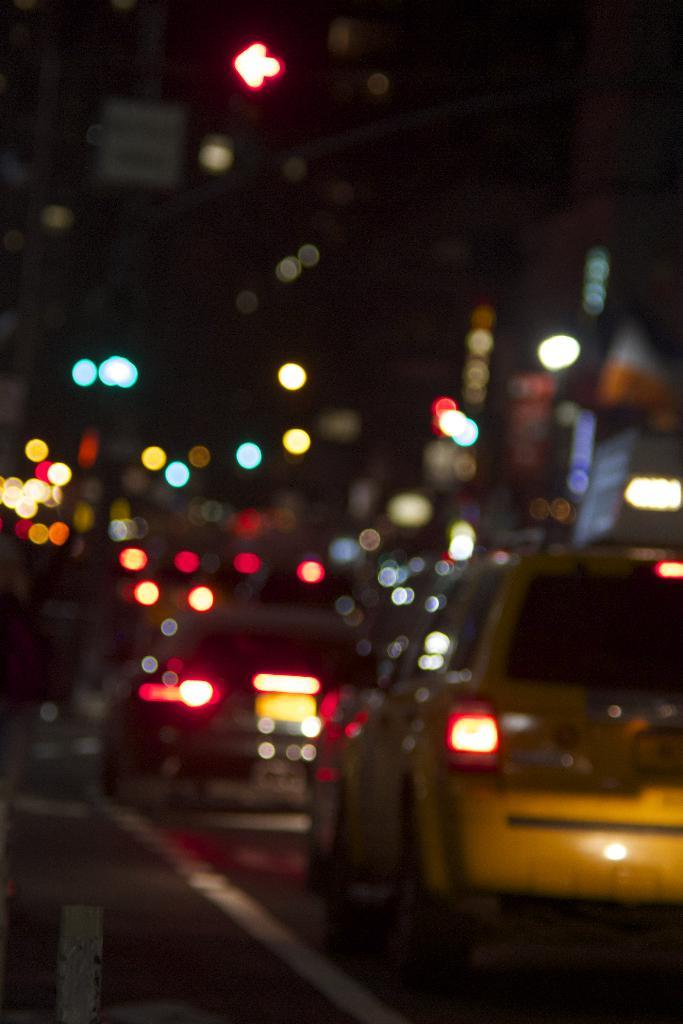What type of vehicles can be seen in the image? There are cars in the image. What else is present in the image besides the cars? There are lights in the image. What type of list is being used to organize the cars in the image? There is no list present in the image; it only shows cars and lights. 